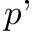Convert formula to latex. <formula><loc_0><loc_0><loc_500><loc_500>p</formula> 